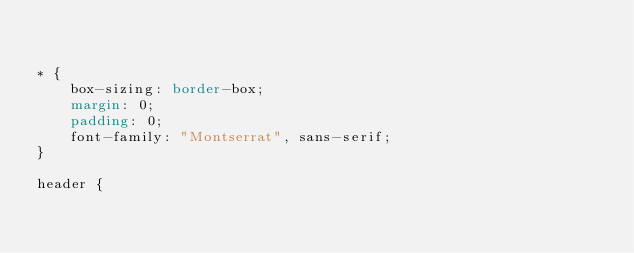<code> <loc_0><loc_0><loc_500><loc_500><_CSS_>

* {
    box-sizing: border-box;
    margin: 0;
    padding: 0;
    font-family: "Montserrat", sans-serif;
}

header {</code> 